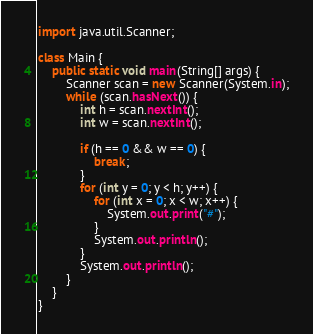Convert code to text. <code><loc_0><loc_0><loc_500><loc_500><_Java_>import java.util.Scanner;

class Main {
    public static void main(String[] args) {
        Scanner scan = new Scanner(System.in);
        while (scan.hasNext()) {
            int h = scan.nextInt();
            int w = scan.nextInt();

            if (h == 0 && w == 0) {
                break;
            }
            for (int y = 0; y < h; y++) {
                for (int x = 0; x < w; x++) {
                    System.out.print("#");
                }
                System.out.println();
            }
            System.out.println();
        }
    }
}</code> 